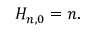<formula> <loc_0><loc_0><loc_500><loc_500>H _ { n , 0 } = n .</formula> 